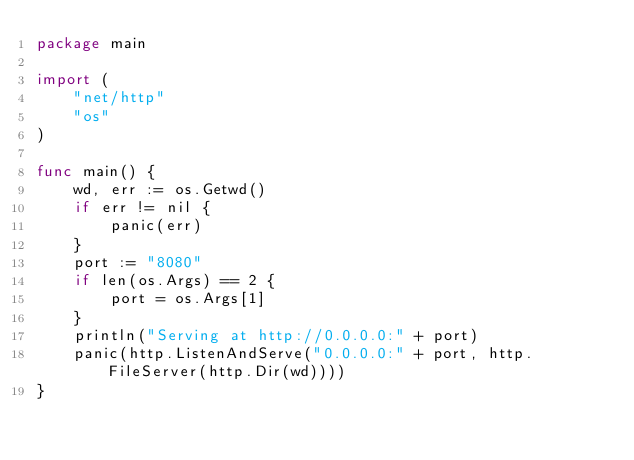<code> <loc_0><loc_0><loc_500><loc_500><_Go_>package main

import (
	"net/http"
	"os"
)

func main() {
	wd, err := os.Getwd()
	if err != nil {
		panic(err)
	}
    port := "8080"
    if len(os.Args) == 2 {
        port = os.Args[1]
    }
	println("Serving at http://0.0.0.0:" + port)
	panic(http.ListenAndServe("0.0.0.0:" + port, http.FileServer(http.Dir(wd))))
}
</code> 